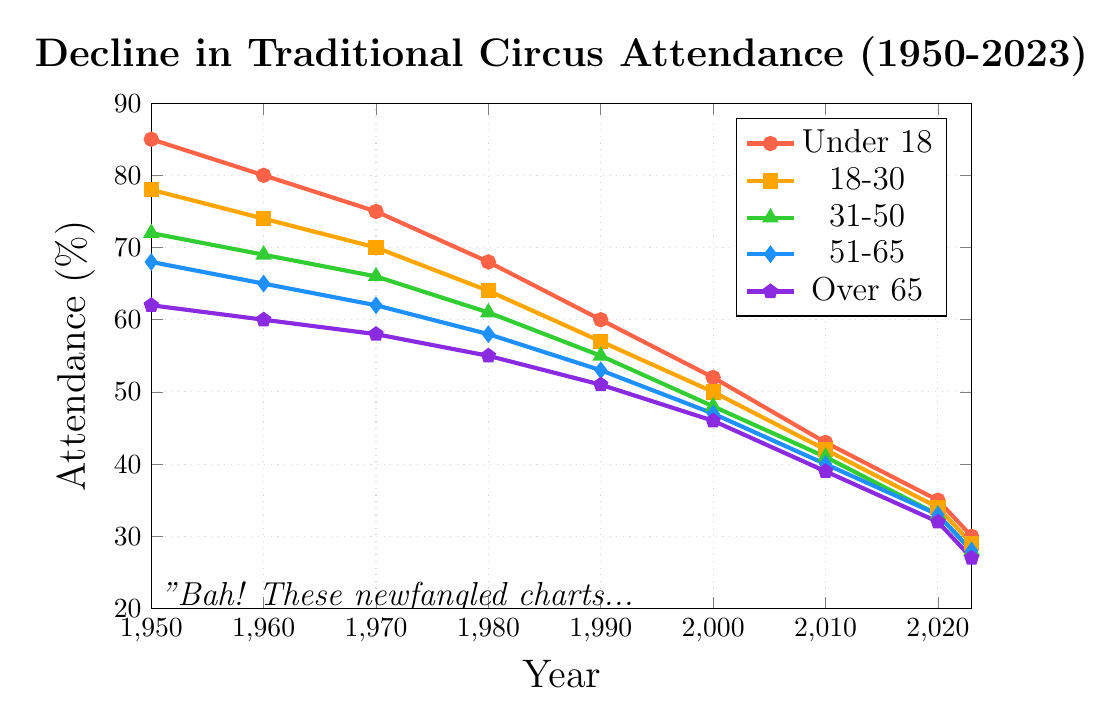Which age group had the highest attendance in 1950? Look for the highest value in the 1950 data points. The under 18 age group has the highest attendance at 85%.
Answer: Under 18 What is the difference in attendance between the 'Under 18' and 'Over 65' groups in 2023? Locate the values for 2023 for both age groups: 30% for 'Under 18' and 27% for 'Over 65'. Subtract the two values: 30% - 27% = 3%.
Answer: 3% Which age group experienced the greatest decline in attendance from 1950 to 2023? Calculate the decline for each age group by subtracting the 2023 value from the 1950 value and find the greatest one.
Under 18: 85% - 30% = 55%
18-30: 78% - 29% = 49%
31-50: 72% - 28% = 44%
51-65: 68% - 28% = 40%
Over 65: 62% - 27% = 35%
The 'Under 18' group experienced the greatest decline at 55%.
Answer: Under 18 By how much did the attendance for the '51-65' age group change between 1960 and 2010? Determine the attendance in 1960 (65%) and 2010 (40%) for the '51-65' age group. Subtract the 2010 value from the 1960 value: 65% - 40% = 25%.
Answer: 25% What was the average attendance for the '31-50' age group across all years? Add the attendance percentages for the '31-50' age group across 1950-2023 and divide by the number of years: (72 + 69 + 66 + 61 + 55 + 48 + 41 + 33 + 28)/9 = 473/9 ≈ 52.56%.
Answer: 52.56% In which decade did the '18-30' age group see the largest drop in attendance, and by how much? Examine the differences between consecutive decades for the '18-30' group:
1950s to 1960s: 78% - 74% = 4%
1960s to 1970s: 74% - 70% = 4%
1970s to 1980s: 70% - 64% = 6%
1980s to 1990s: 64% - 57% = 7%
1990s to 2000s: 57% - 50% = 7%
2000s to 2010s: 50% - 42% = 8%
2010s to 2020s: 42% - 34% = 8%
2010s to 2023: 34% - 29% = 5%
The largest drop occurred between the 2000s and 2010s, by 8%.
Answer: 2000s to 2010s, 8% Between which two consecutive years did the 'Under 18' age group see the most significant decline in attendance? Compare the changes in attendance for the 'Under 18' group year by year:
1950-1960: 85% - 80% = 5%
1960-1970: 80% - 75% = 5%
1970-1980: 75% - 68% = 7%
1980-1990: 68% - 60% = 8%
1990-2000: 60% - 52% = 8%
2000-2010: 52% - 43% = 9%
2010-2020: 43% - 35% = 8%
2020-2023: 35% - 30% = 5%
The most significant decline occurred between 2000 and 2010, by 9%.
Answer: 2000 and 2010, 9% Which age group had the closest attendance values between 2020 and 2023? Find the differences in attendance for each age group between 2020 and 2023:
Under 18: 35% - 30% = 5%
18-30: 34% - 29% = 5%
31-50: 33% - 28% = 5%
51-65: 33% - 28% = 5%
Over 65: 32% - 27% = 5%
All groups had the same difference of 5%.
Answer: All groups had the same difference, 5% If the average attendance in 2000 was calculated from the two youngest age groups, what would it be? Add the 2000 attendance for 'Under 18' (52%) and '18-30' (50%) and divide by 2: (52 + 50) / 2 = 51%.
Answer: 51% 